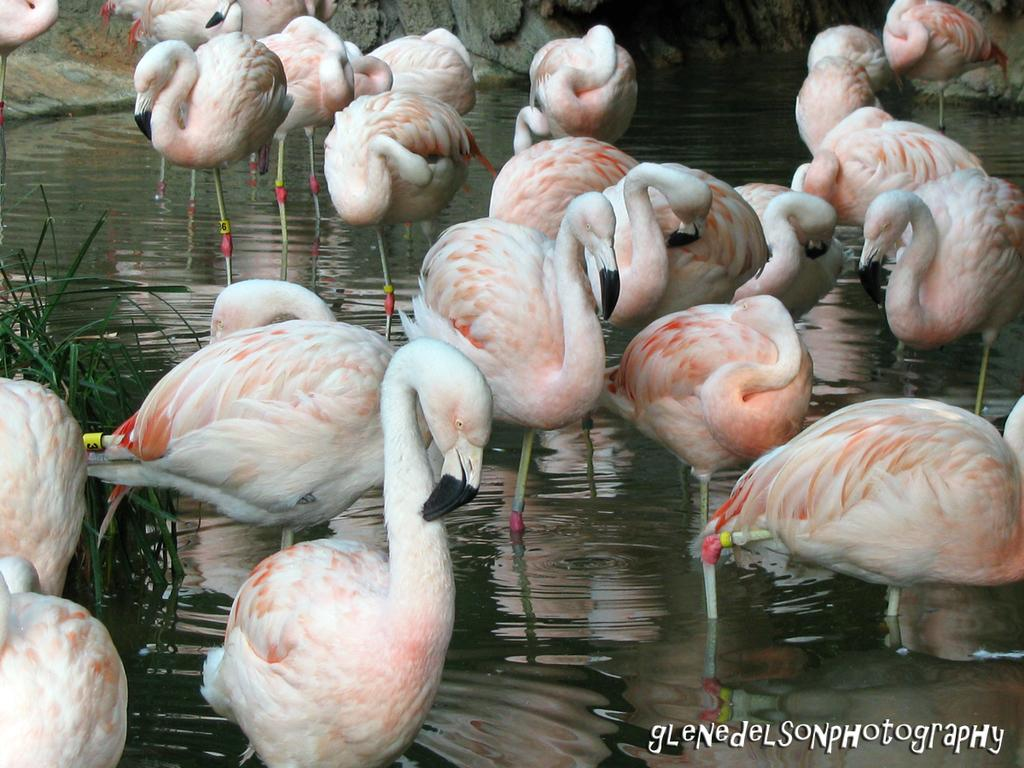What type of birds are in the foreground of the image? There are greater flamingos in the foreground of the image. Where are the greater flamingos located? The greater flamingos are in the water. What can be seen on the right side of the image? There is grass on the right side of the image. Is the grass in the water or on land? The grass is in the water. What type of watch can be seen on the greater flamingo's leg in the image? There are no watches present in the image; the greater flamingos are not wearing any accessories. 